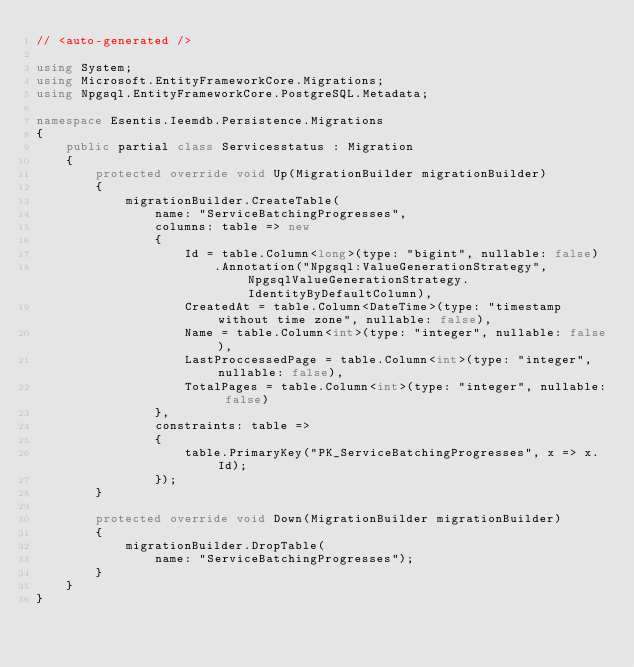Convert code to text. <code><loc_0><loc_0><loc_500><loc_500><_C#_>// <auto-generated />

using System;
using Microsoft.EntityFrameworkCore.Migrations;
using Npgsql.EntityFrameworkCore.PostgreSQL.Metadata;

namespace Esentis.Ieemdb.Persistence.Migrations
{
    public partial class Servicesstatus : Migration
    {
        protected override void Up(MigrationBuilder migrationBuilder)
        {
            migrationBuilder.CreateTable(
                name: "ServiceBatchingProgresses",
                columns: table => new
                {
                    Id = table.Column<long>(type: "bigint", nullable: false)
                        .Annotation("Npgsql:ValueGenerationStrategy", NpgsqlValueGenerationStrategy.IdentityByDefaultColumn),
                    CreatedAt = table.Column<DateTime>(type: "timestamp without time zone", nullable: false),
                    Name = table.Column<int>(type: "integer", nullable: false),
                    LastProccessedPage = table.Column<int>(type: "integer", nullable: false),
                    TotalPages = table.Column<int>(type: "integer", nullable: false)
                },
                constraints: table =>
                {
                    table.PrimaryKey("PK_ServiceBatchingProgresses", x => x.Id);
                });
        }

        protected override void Down(MigrationBuilder migrationBuilder)
        {
            migrationBuilder.DropTable(
                name: "ServiceBatchingProgresses");
        }
    }
}
</code> 